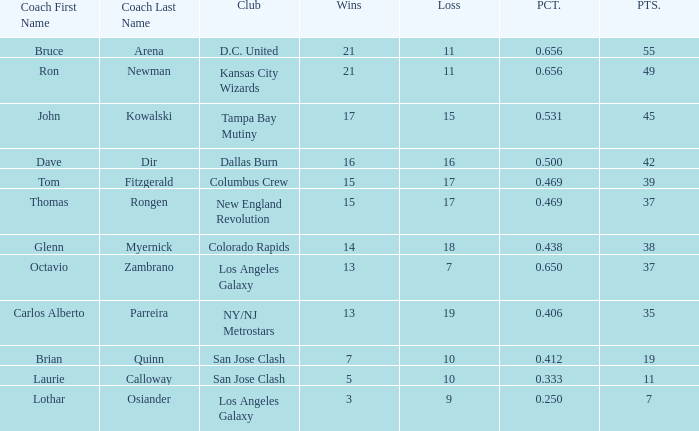What is the highest percent of Bruce Arena when he loses more than 11 games? None. 